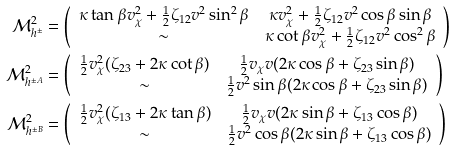<formula> <loc_0><loc_0><loc_500><loc_500>\mathcal { M } ^ { 2 } _ { h ^ { \pm } } & = \left ( \begin{array} { c c } \kappa \tan \beta v _ { \chi } ^ { 2 } + \frac { 1 } { 2 } \zeta _ { 1 2 } v ^ { 2 } \sin ^ { 2 } \beta & \kappa v _ { \chi } ^ { 2 } + \frac { 1 } { 2 } \zeta _ { 1 2 } v ^ { 2 } \cos \beta \sin \beta \\ \sim & \kappa \cot \beta v _ { \chi } ^ { 2 } + \frac { 1 } { 2 } \zeta _ { 1 2 } v ^ { 2 } \cos ^ { 2 } \beta \\ \end{array} \right ) \\ \mathcal { M } ^ { 2 } _ { h ^ { \pm A } } & = \left ( \begin{array} { c c } \frac { 1 } { 2 } v _ { \chi } ^ { 2 } ( \zeta _ { 2 3 } + 2 \kappa \cot \beta ) & \frac { 1 } { 2 } v _ { \chi } v ( 2 \kappa \cos \beta + \zeta _ { 2 3 } \sin \beta ) \\ \sim & \frac { 1 } { 2 } v ^ { 2 } \sin \beta ( 2 \kappa \cos \beta + \zeta _ { 2 3 } \sin \beta ) \\ \end{array} \right ) \\ \mathcal { M } ^ { 2 } _ { h ^ { \pm B } } & = \left ( \begin{array} { c c } \frac { 1 } { 2 } v _ { \chi } ^ { 2 } ( \zeta _ { 1 3 } + 2 \kappa \tan \beta ) & \frac { 1 } { 2 } v _ { \chi } v ( 2 \kappa \sin \beta + \zeta _ { 1 3 } \cos \beta ) \\ \sim & \frac { 1 } { 2 } v ^ { 2 } \cos \beta ( 2 \kappa \sin \beta + \zeta _ { 1 3 } \cos \beta ) \\ \end{array} \right )</formula> 